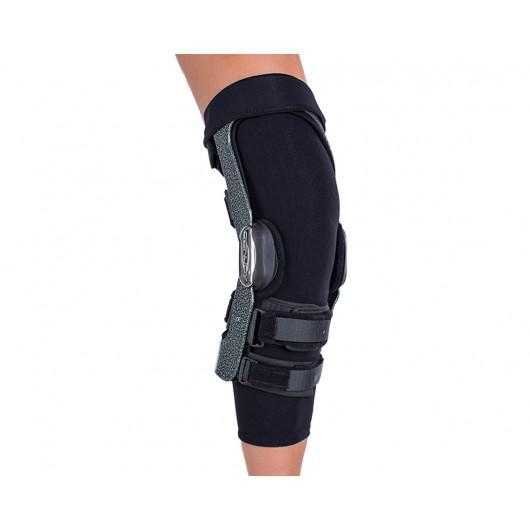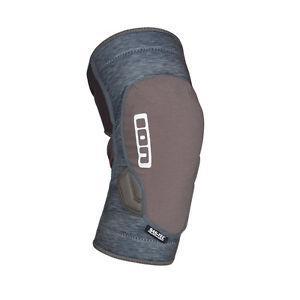The first image is the image on the left, the second image is the image on the right. Examine the images to the left and right. Is the description "The knee braces in the two images face the same direction." accurate? Answer yes or no. Yes. 